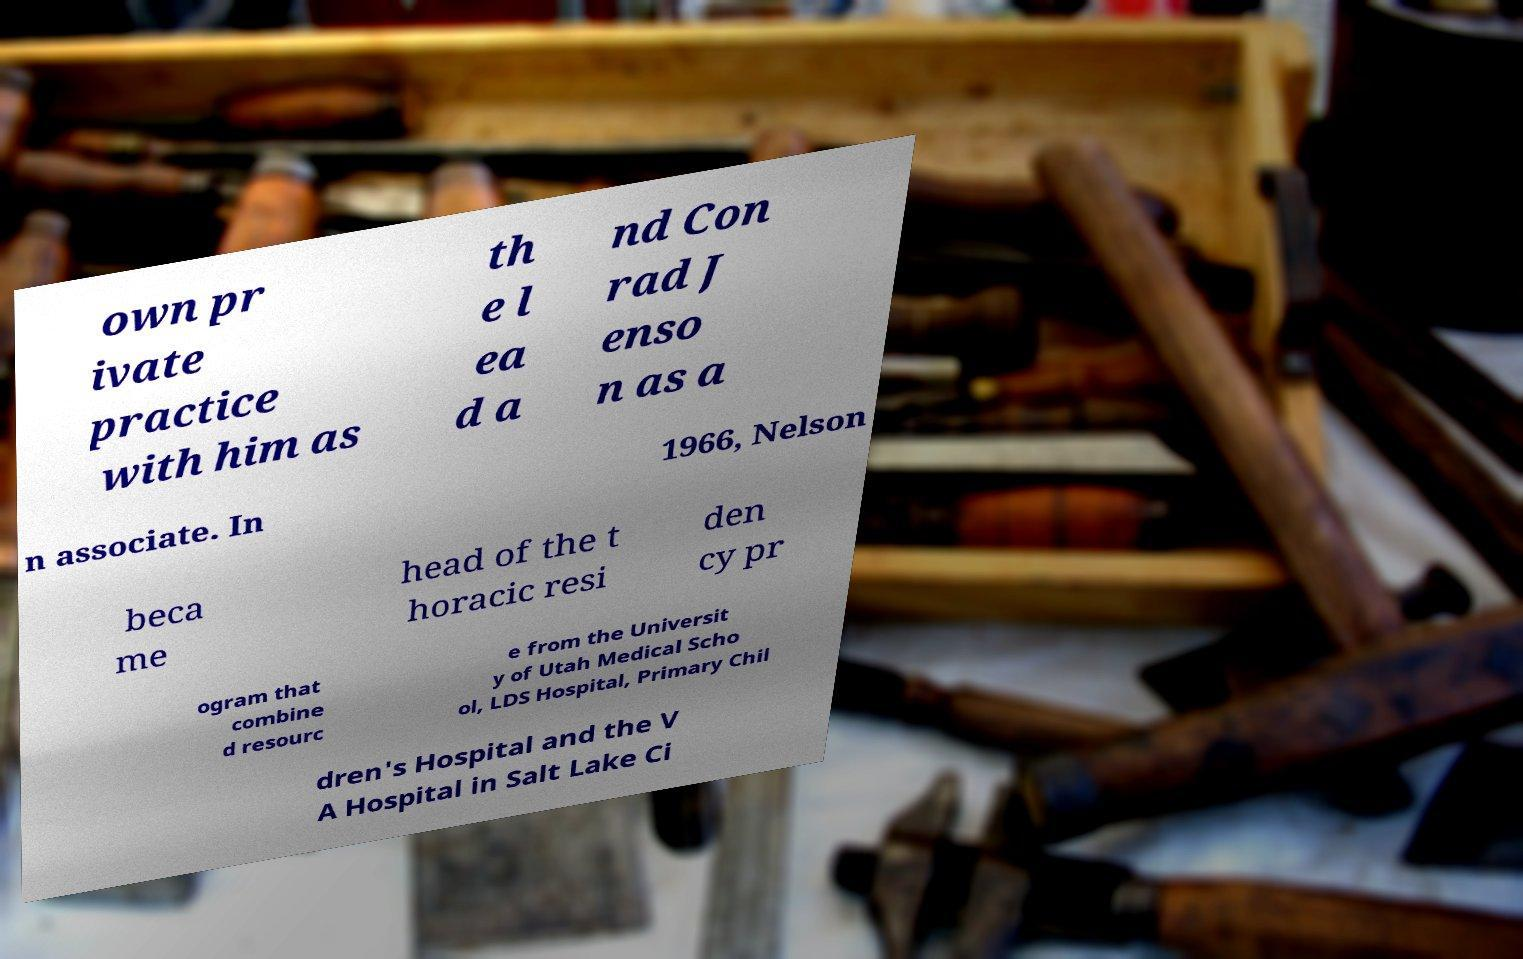Please read and relay the text visible in this image. What does it say? own pr ivate practice with him as th e l ea d a nd Con rad J enso n as a n associate. In 1966, Nelson beca me head of the t horacic resi den cy pr ogram that combine d resourc e from the Universit y of Utah Medical Scho ol, LDS Hospital, Primary Chil dren's Hospital and the V A Hospital in Salt Lake Ci 